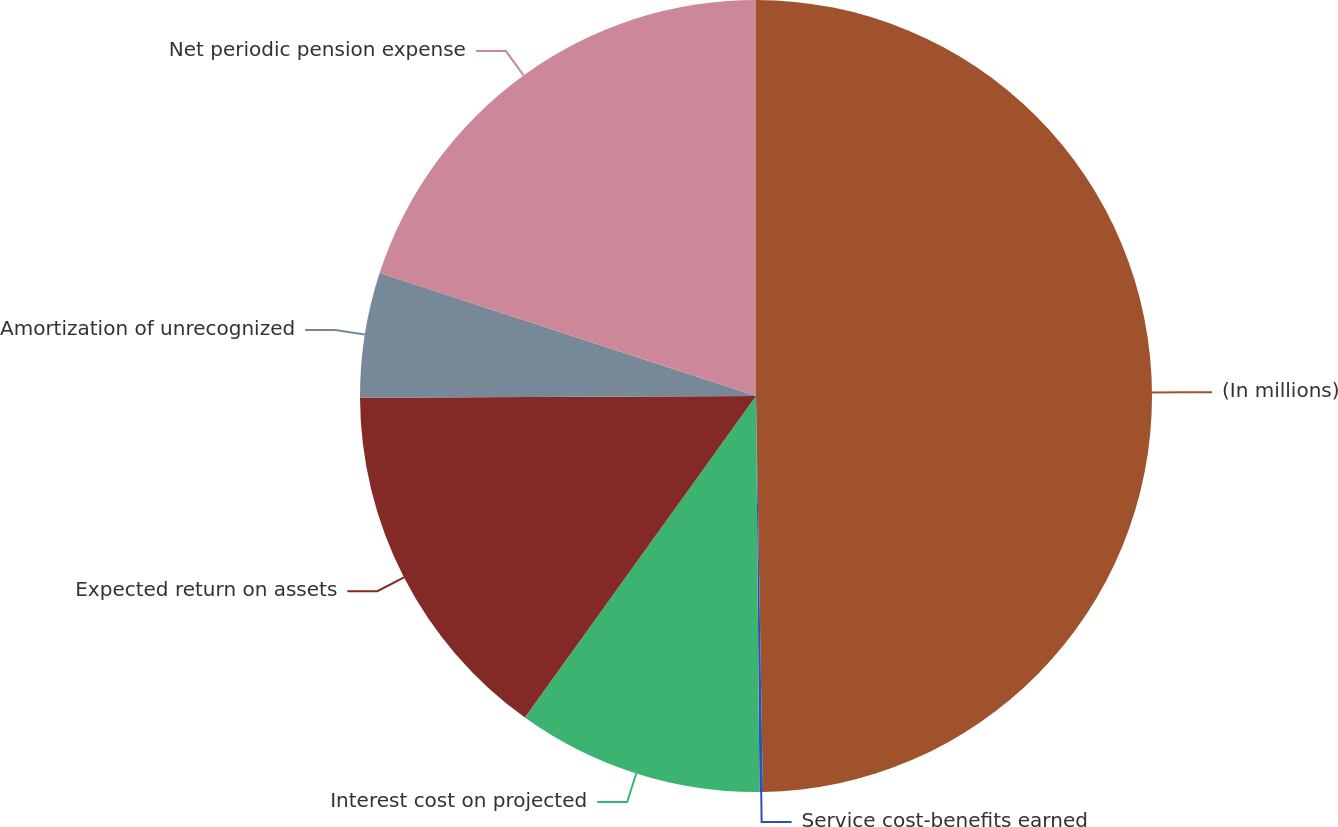Convert chart. <chart><loc_0><loc_0><loc_500><loc_500><pie_chart><fcel>(In millions)<fcel>Service cost-benefits earned<fcel>Interest cost on projected<fcel>Expected return on assets<fcel>Amortization of unrecognized<fcel>Net periodic pension expense<nl><fcel>49.72%<fcel>0.14%<fcel>10.06%<fcel>15.01%<fcel>5.1%<fcel>19.97%<nl></chart> 